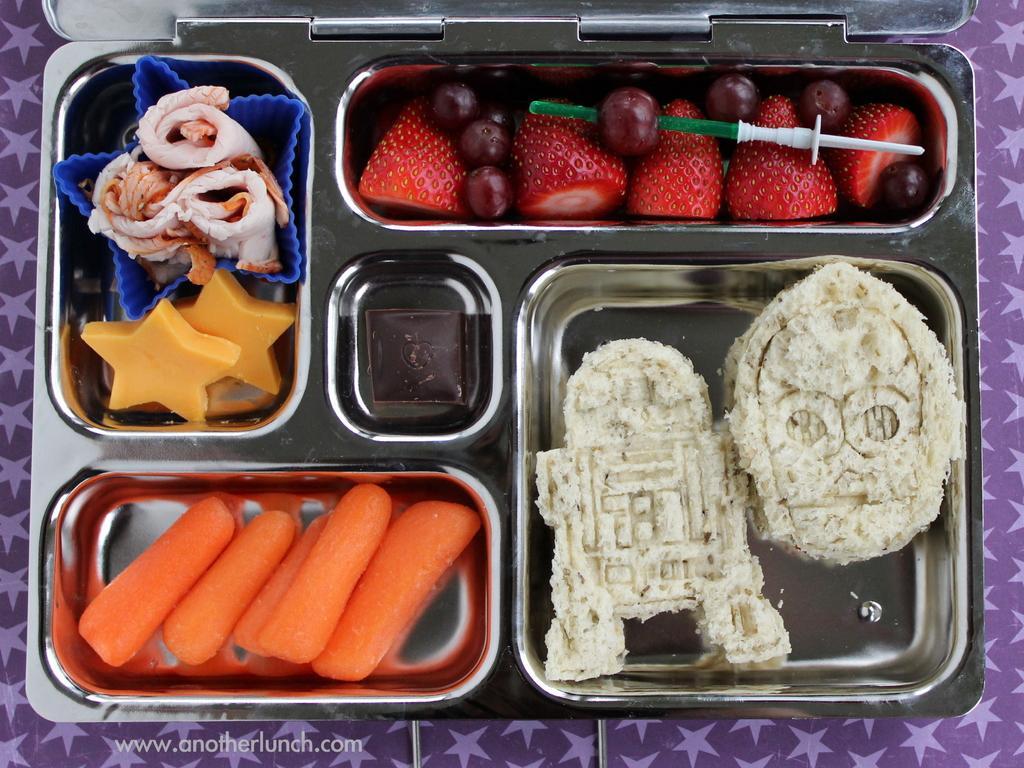Could you give a brief overview of what you see in this image? In this image I can see food items in steel plate. They are in orange,white,red,brown,yellow and cream color. Background is in purple color. 